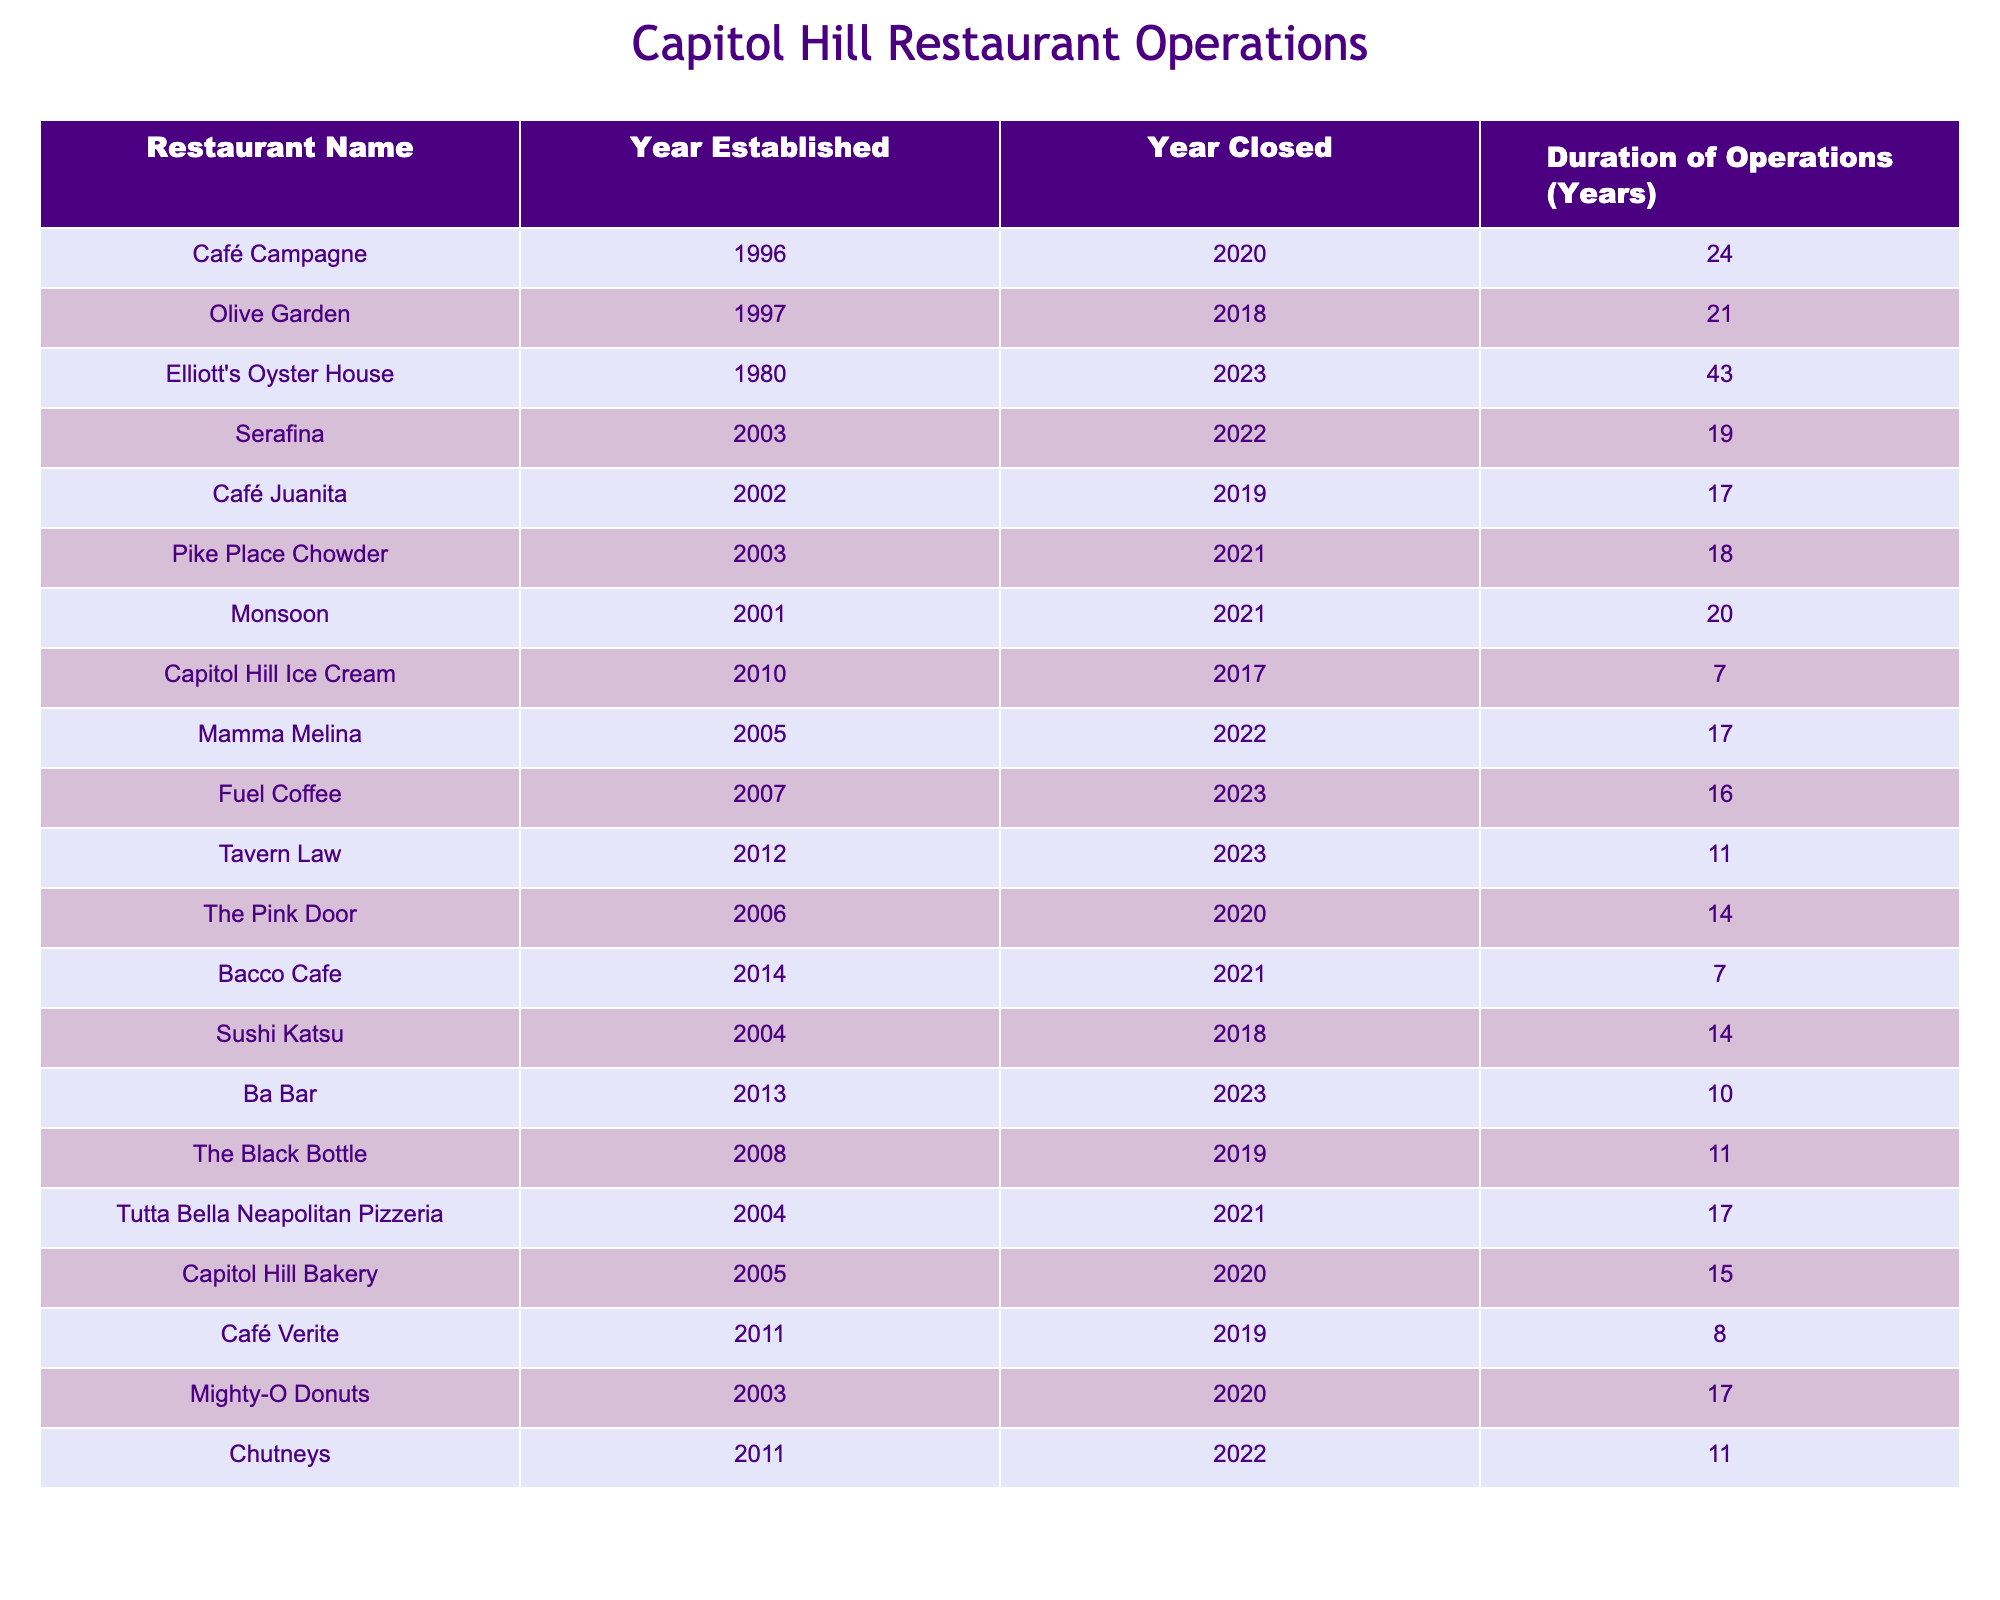What is the average duration of operations for the restaurants listed? To find the average duration, we add up all the durations from the table. The sum is (24 + 21 + 43 + 19 + 17 + 18 + 20 + 7 + 17 + 16 + 11 + 14 + 7 + 14 + 10 + 11 + 17 + 15 + 8 + 17 + 11) =  414. There are 20 restaurants, so we divide the sum by 20: 414/20 = 20.7.
Answer: 20.7 Which restaurant has the longest duration of operations? By looking at the "Duration of Operations" column, Elliott's Oyster House has the highest number of years at 43.
Answer: Elliott's Oyster House What year did Café Campagne close? The table shows that Café Campagne was established in 1996 and closed in 2020.
Answer: 2020 Is the average duration of operations for restaurants that closed before 2020 more than 15 years? To determine this, we first find the durations of the restaurants that closed before 2020: Olive Garden (21), Café Juanita (17), Capitol Hill Ice Cream (7), Bacco Cafe (7), Sushi Katsu (14), and The Black Bottle (11). The sum is 21 + 17 + 7 + 7 + 14 + 11 = 77. There are 6 restaurants, therefore the average is 77/6 = 12.83, which is not more than 15.
Answer: No How many restaurants had a duration of operations greater than 15 years? We can filter the table to count only those with durations exceeding 15 years. The relevant restaurants are Elliott's Oyster House (43), Café Campagne (24), Olive Garden (21), Monsoon (20), Mighty-O Donuts (17), Tutt Bella Neapolitan Pizzeria (17), Fuel Coffee (16), Serafina (19), and Mamma Melina (17). In total, there are 9 restaurants with durations greater than 15 years.
Answer: 9 Did all restaurants established after 2010 last for more than 5 years? Looking at the restaurants established after 2010: Fuel Coffee (16), Tavern Law (11), Ba Bar (10), Chutneys (11), and Capitol Hill Bakery (15). All of them have durations greater than 5 years, so the answer is yes.
Answer: Yes What is the median duration of operations for the restaurants listed? First, we sort the durations in order: 7, 7, 8, 10, 11, 11, 14, 14, 15, 16, 17, 17, 17, 19, 20, 21, 24, 43. There are 20 entries, so the median is the average of the 10th and 11th values (16 and 17), giving us (16 + 17)/2 = 16.5.
Answer: 16.5 Which restaurant lasted the shortest time before closing? In the table, Capitol Hill Ice Cream has the shortest duration at 7 years.
Answer: Capitol Hill Ice Cream How many restaurants closed between 2021 and 2022? We review the table for those that fall in this closure period. The following restaurants closed during this time: Pike Place Chowder (2021), Monsoon (2021), Mamma Melina (2022), and Chutneys (2022). This gives us a total of 4 restaurants.
Answer: 4 